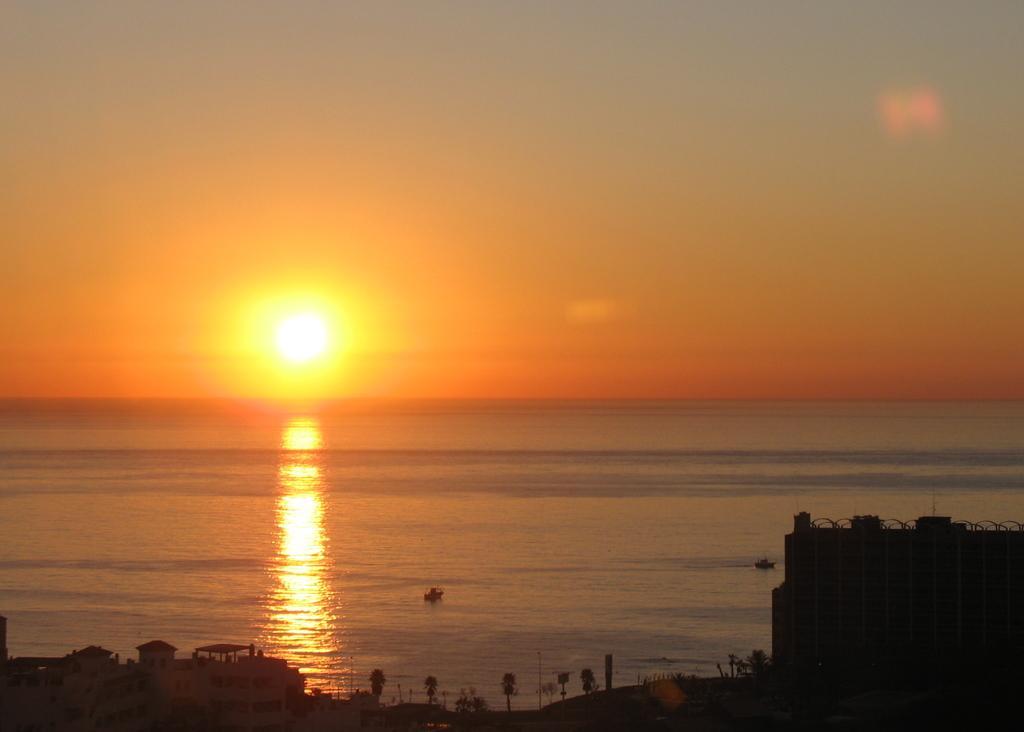In one or two sentences, can you explain what this image depicts? In this image we can see buildings, trees, two objects on the water looks like boats and in the background there are sky and sun. 